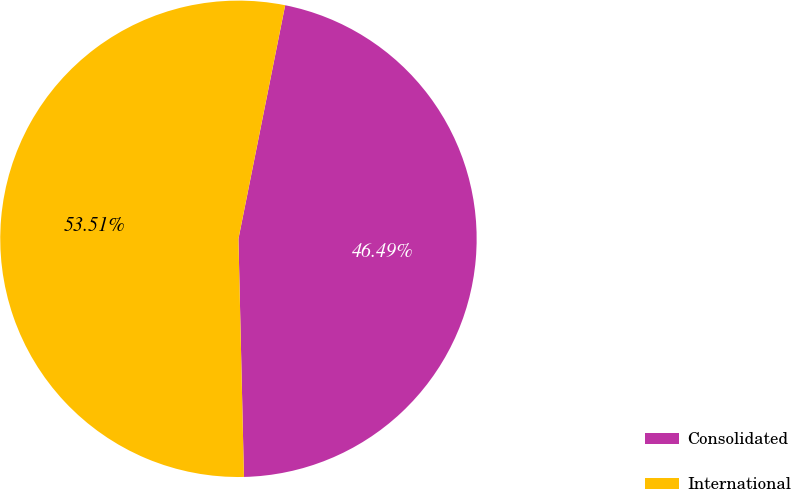<chart> <loc_0><loc_0><loc_500><loc_500><pie_chart><fcel>Consolidated<fcel>International<nl><fcel>46.49%<fcel>53.51%<nl></chart> 